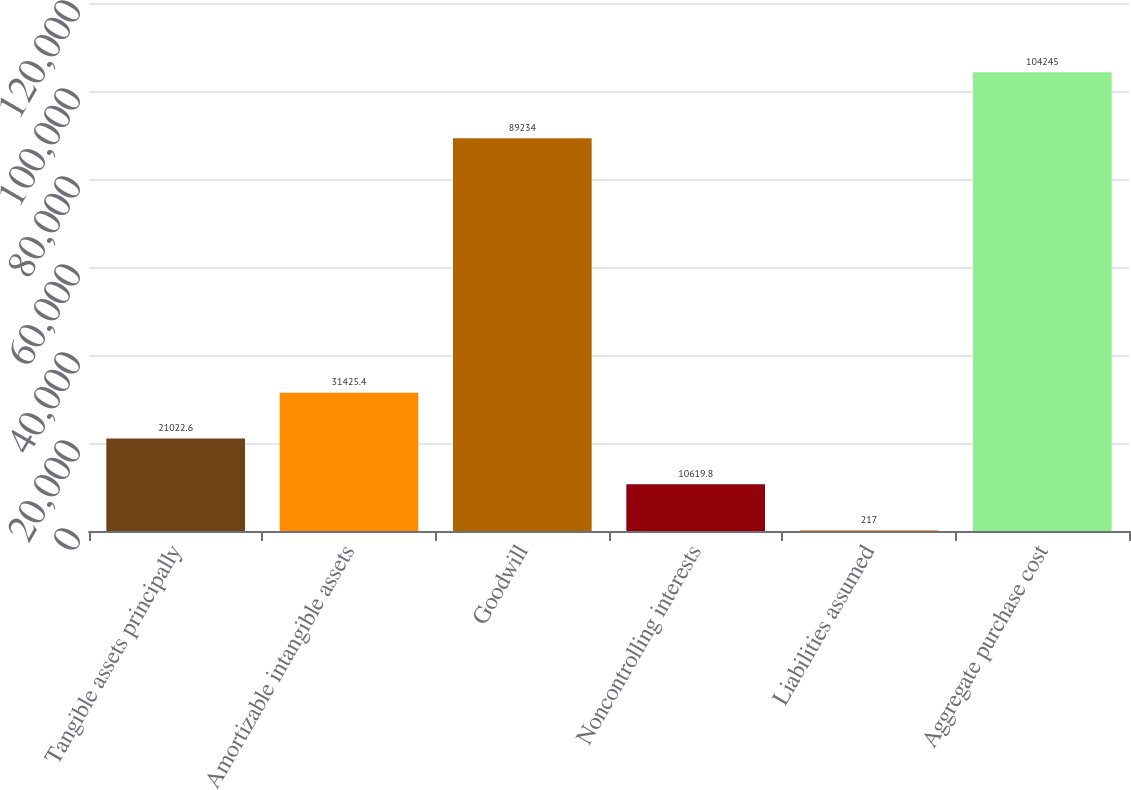<chart> <loc_0><loc_0><loc_500><loc_500><bar_chart><fcel>Tangible assets principally<fcel>Amortizable intangible assets<fcel>Goodwill<fcel>Noncontrolling interests<fcel>Liabilities assumed<fcel>Aggregate purchase cost<nl><fcel>21022.6<fcel>31425.4<fcel>89234<fcel>10619.8<fcel>217<fcel>104245<nl></chart> 